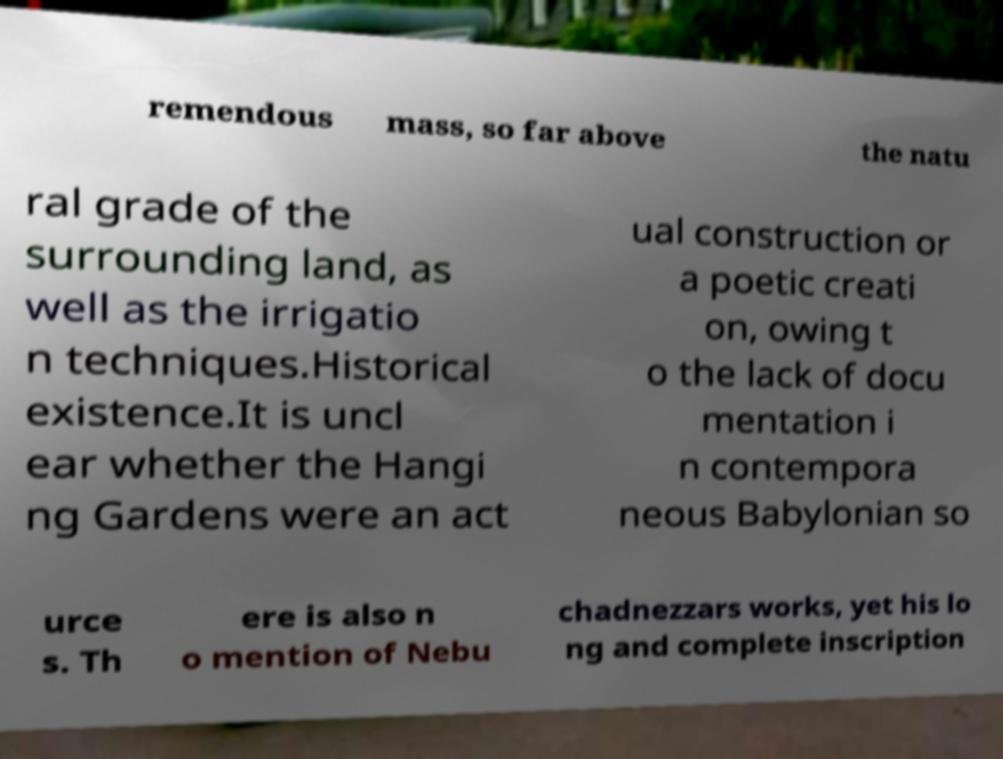What messages or text are displayed in this image? I need them in a readable, typed format. remendous mass, so far above the natu ral grade of the surrounding land, as well as the irrigatio n techniques.Historical existence.It is uncl ear whether the Hangi ng Gardens were an act ual construction or a poetic creati on, owing t o the lack of docu mentation i n contempora neous Babylonian so urce s. Th ere is also n o mention of Nebu chadnezzars works, yet his lo ng and complete inscription 